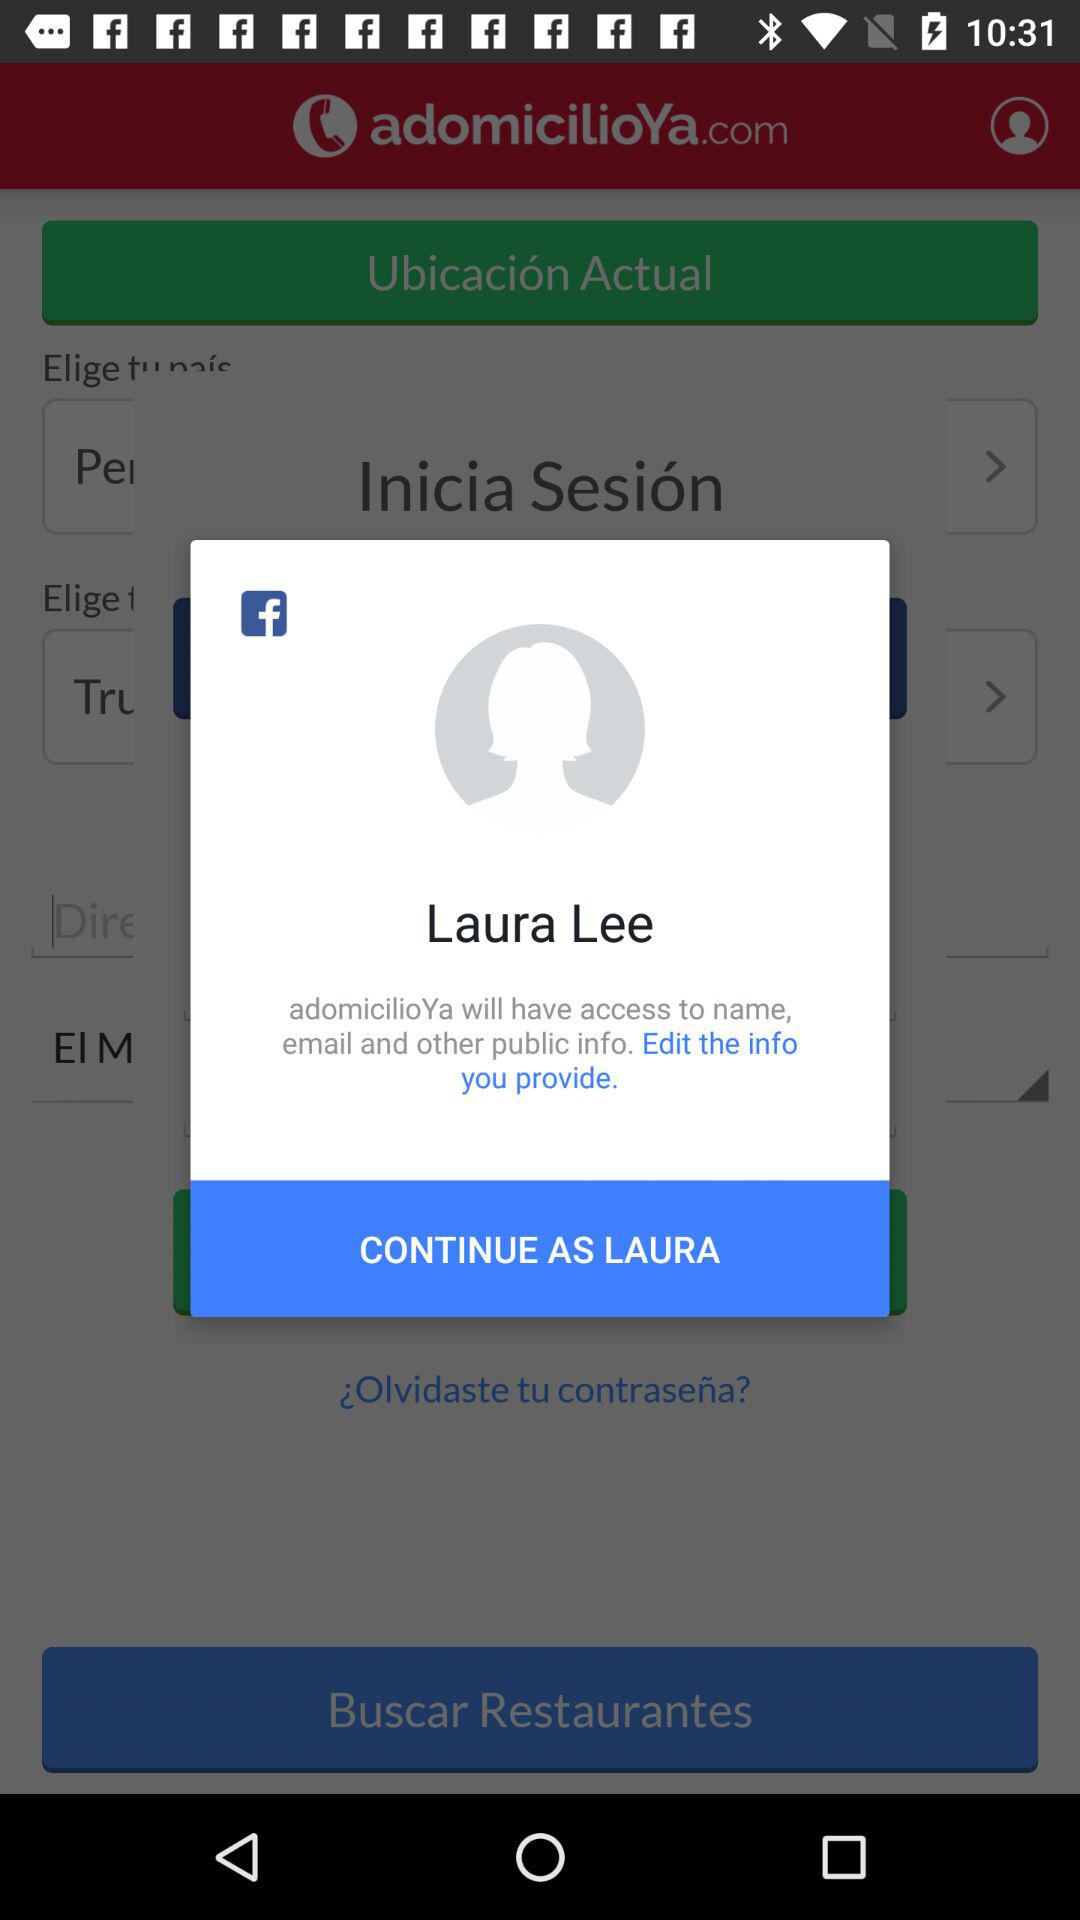What application is asking for permission? The application "adomicilioYa" is asking for permission. 